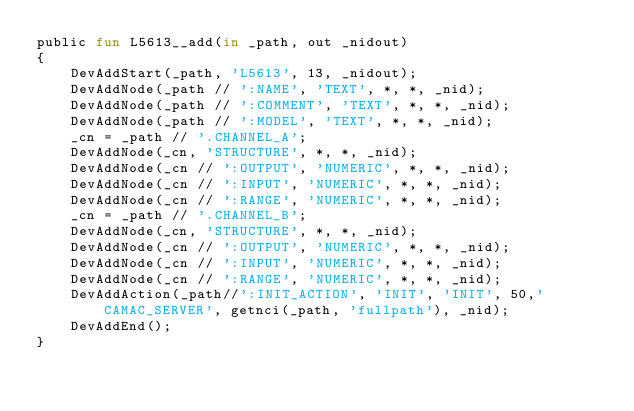<code> <loc_0><loc_0><loc_500><loc_500><_SML_>public fun L5613__add(in _path, out _nidout)
{
    DevAddStart(_path, 'L5613', 13, _nidout);
    DevAddNode(_path // ':NAME', 'TEXT', *, *, _nid);
    DevAddNode(_path // ':COMMENT', 'TEXT', *, *, _nid);
    DevAddNode(_path // ':MODEL', 'TEXT', *, *, _nid);
    _cn = _path // '.CHANNEL_A';
    DevAddNode(_cn, 'STRUCTURE', *, *, _nid);
    DevAddNode(_cn // ':OUTPUT', 'NUMERIC', *, *, _nid);
    DevAddNode(_cn // ':INPUT', 'NUMERIC', *, *, _nid);
    DevAddNode(_cn // ':RANGE', 'NUMERIC', *, *, _nid);
    _cn = _path // '.CHANNEL_B';
    DevAddNode(_cn, 'STRUCTURE', *, *, _nid);
    DevAddNode(_cn // ':OUTPUT', 'NUMERIC', *, *, _nid);
    DevAddNode(_cn // ':INPUT', 'NUMERIC', *, *, _nid);
    DevAddNode(_cn // ':RANGE', 'NUMERIC', *, *, _nid);
    DevAddAction(_path//':INIT_ACTION', 'INIT', 'INIT', 50,'CAMAC_SERVER', getnci(_path, 'fullpath'), _nid);
    DevAddEnd();
}
</code> 